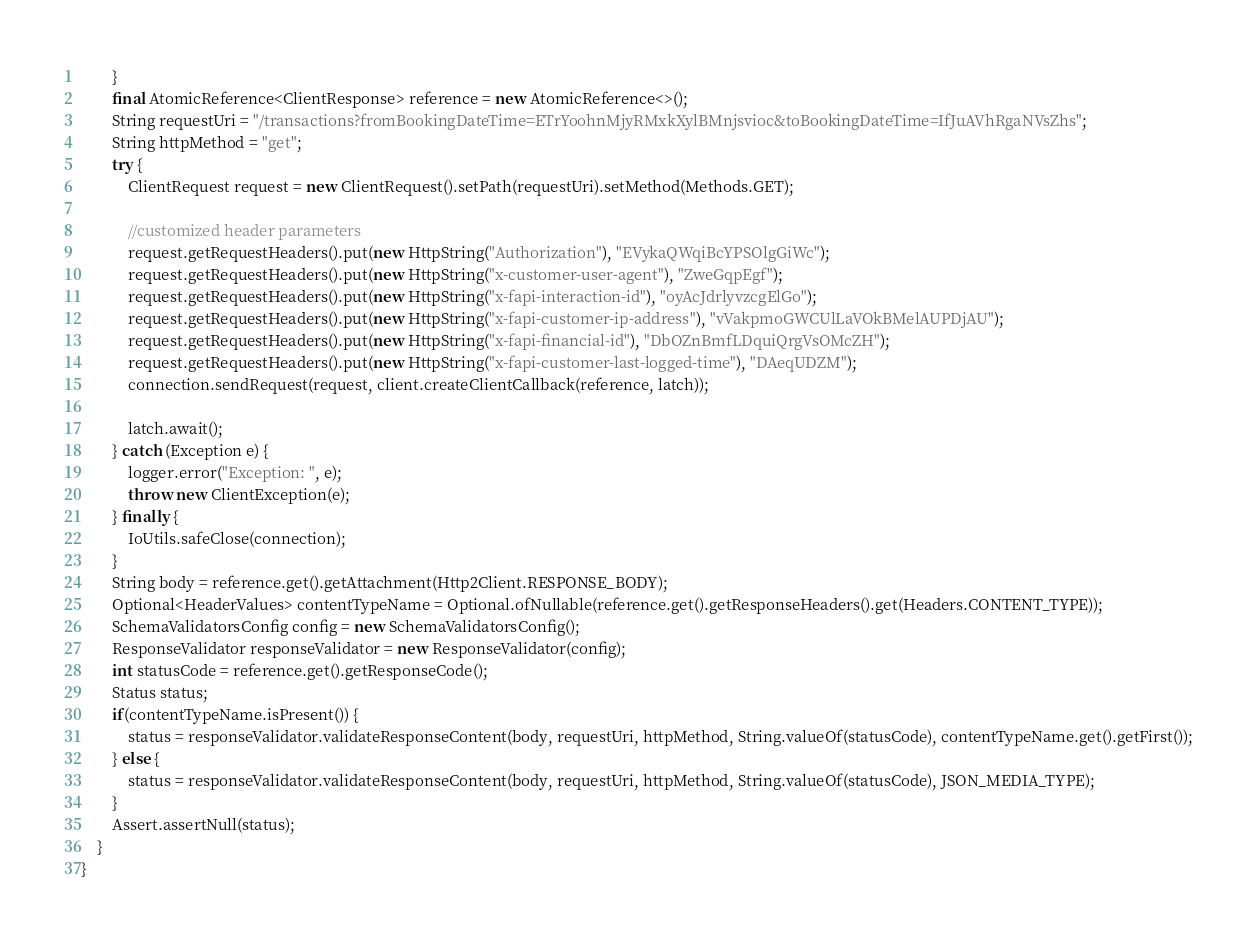Convert code to text. <code><loc_0><loc_0><loc_500><loc_500><_Java_>        }
        final AtomicReference<ClientResponse> reference = new AtomicReference<>();
        String requestUri = "/transactions?fromBookingDateTime=ETrYoohnMjyRMxkXylBMnjsvioc&toBookingDateTime=IfJuAVhRgaNVsZhs";
        String httpMethod = "get";
        try {
            ClientRequest request = new ClientRequest().setPath(requestUri).setMethod(Methods.GET);
            
            //customized header parameters 
            request.getRequestHeaders().put(new HttpString("Authorization"), "EVykaQWqiBcYPSOlgGiWc");
            request.getRequestHeaders().put(new HttpString("x-customer-user-agent"), "ZweGqpEgf");
            request.getRequestHeaders().put(new HttpString("x-fapi-interaction-id"), "oyAcJdrlyvzcgElGo");
            request.getRequestHeaders().put(new HttpString("x-fapi-customer-ip-address"), "vVakpmoGWCUlLaVOkBMelAUPDjAU");
            request.getRequestHeaders().put(new HttpString("x-fapi-financial-id"), "DbOZnBmfLDquiQrgVsOMcZH");
            request.getRequestHeaders().put(new HttpString("x-fapi-customer-last-logged-time"), "DAeqUDZM");
            connection.sendRequest(request, client.createClientCallback(reference, latch));
            
            latch.await();
        } catch (Exception e) {
            logger.error("Exception: ", e);
            throw new ClientException(e);
        } finally {
            IoUtils.safeClose(connection);
        }
        String body = reference.get().getAttachment(Http2Client.RESPONSE_BODY);
        Optional<HeaderValues> contentTypeName = Optional.ofNullable(reference.get().getResponseHeaders().get(Headers.CONTENT_TYPE));
        SchemaValidatorsConfig config = new SchemaValidatorsConfig();
        ResponseValidator responseValidator = new ResponseValidator(config);
        int statusCode = reference.get().getResponseCode();
        Status status;
        if(contentTypeName.isPresent()) {
            status = responseValidator.validateResponseContent(body, requestUri, httpMethod, String.valueOf(statusCode), contentTypeName.get().getFirst());
        } else {
            status = responseValidator.validateResponseContent(body, requestUri, httpMethod, String.valueOf(statusCode), JSON_MEDIA_TYPE);
        }
        Assert.assertNull(status);
    }
}

</code> 